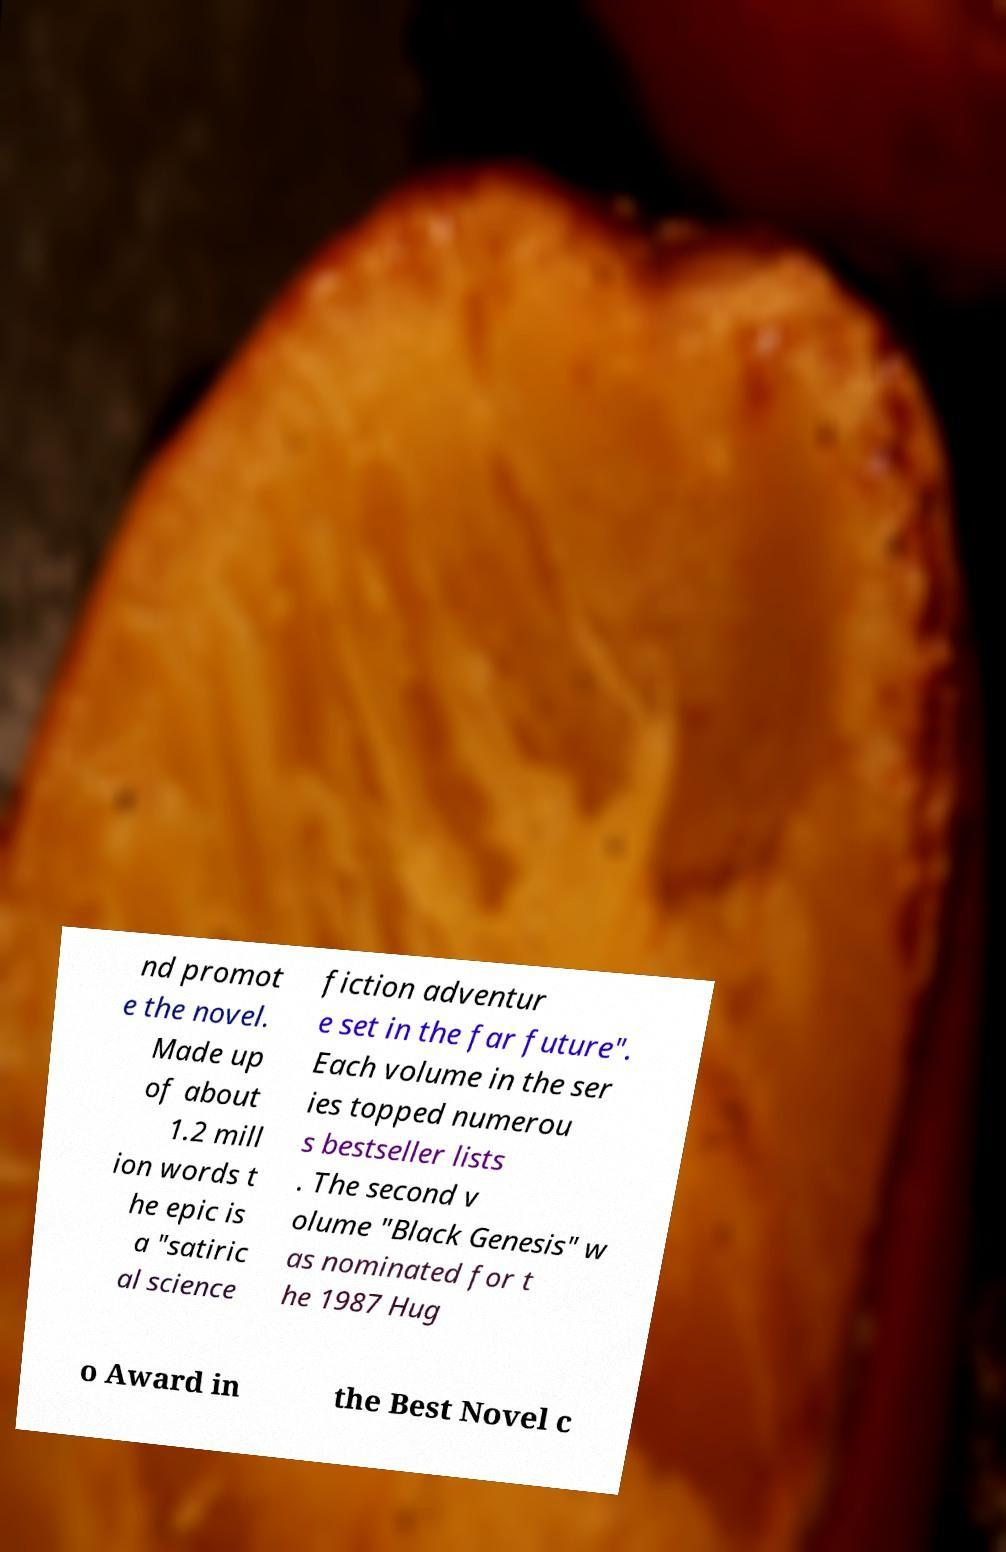Can you read and provide the text displayed in the image?This photo seems to have some interesting text. Can you extract and type it out for me? nd promot e the novel. Made up of about 1.2 mill ion words t he epic is a "satiric al science fiction adventur e set in the far future". Each volume in the ser ies topped numerou s bestseller lists . The second v olume "Black Genesis" w as nominated for t he 1987 Hug o Award in the Best Novel c 